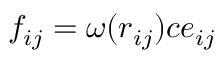Convert formula to latex. <formula><loc_0><loc_0><loc_500><loc_500>f _ { i j } = \omega ( r _ { i j } ) c e _ { i j }</formula> 